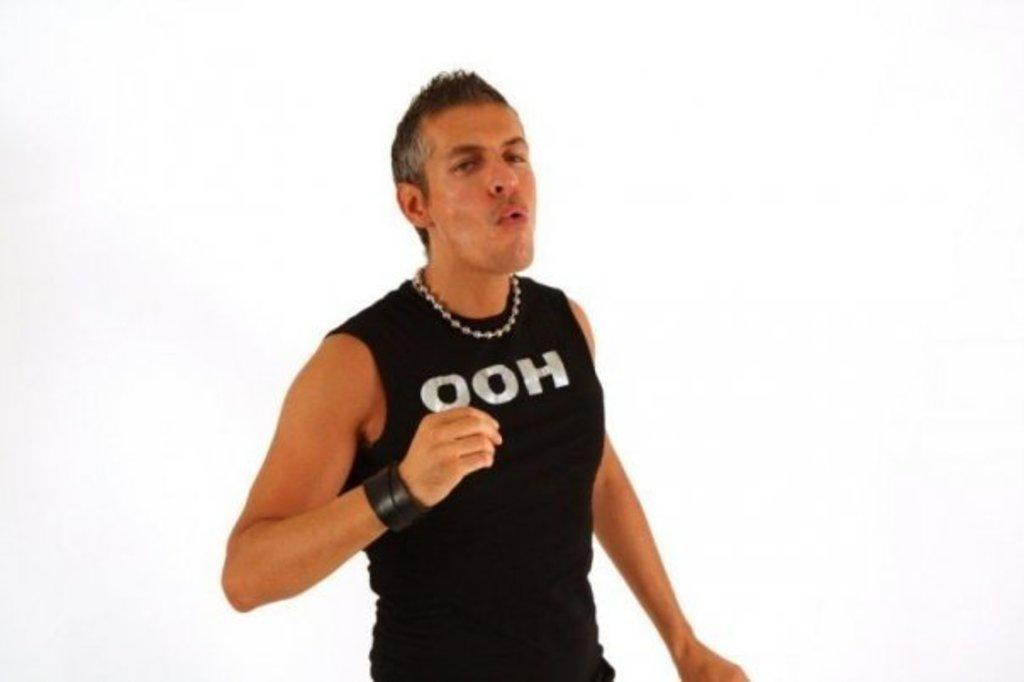<image>
Render a clear and concise summary of the photo. A man is wearing a black tank top with, "ooh" on the front. 